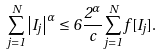<formula> <loc_0><loc_0><loc_500><loc_500>\sum _ { j = 1 } ^ { N } \left | I _ { j } \right | ^ { \alpha } \leq 6 \frac { 2 ^ { \alpha } } { c } \sum _ { j = 1 } ^ { N } f [ I _ { j } ] .</formula> 